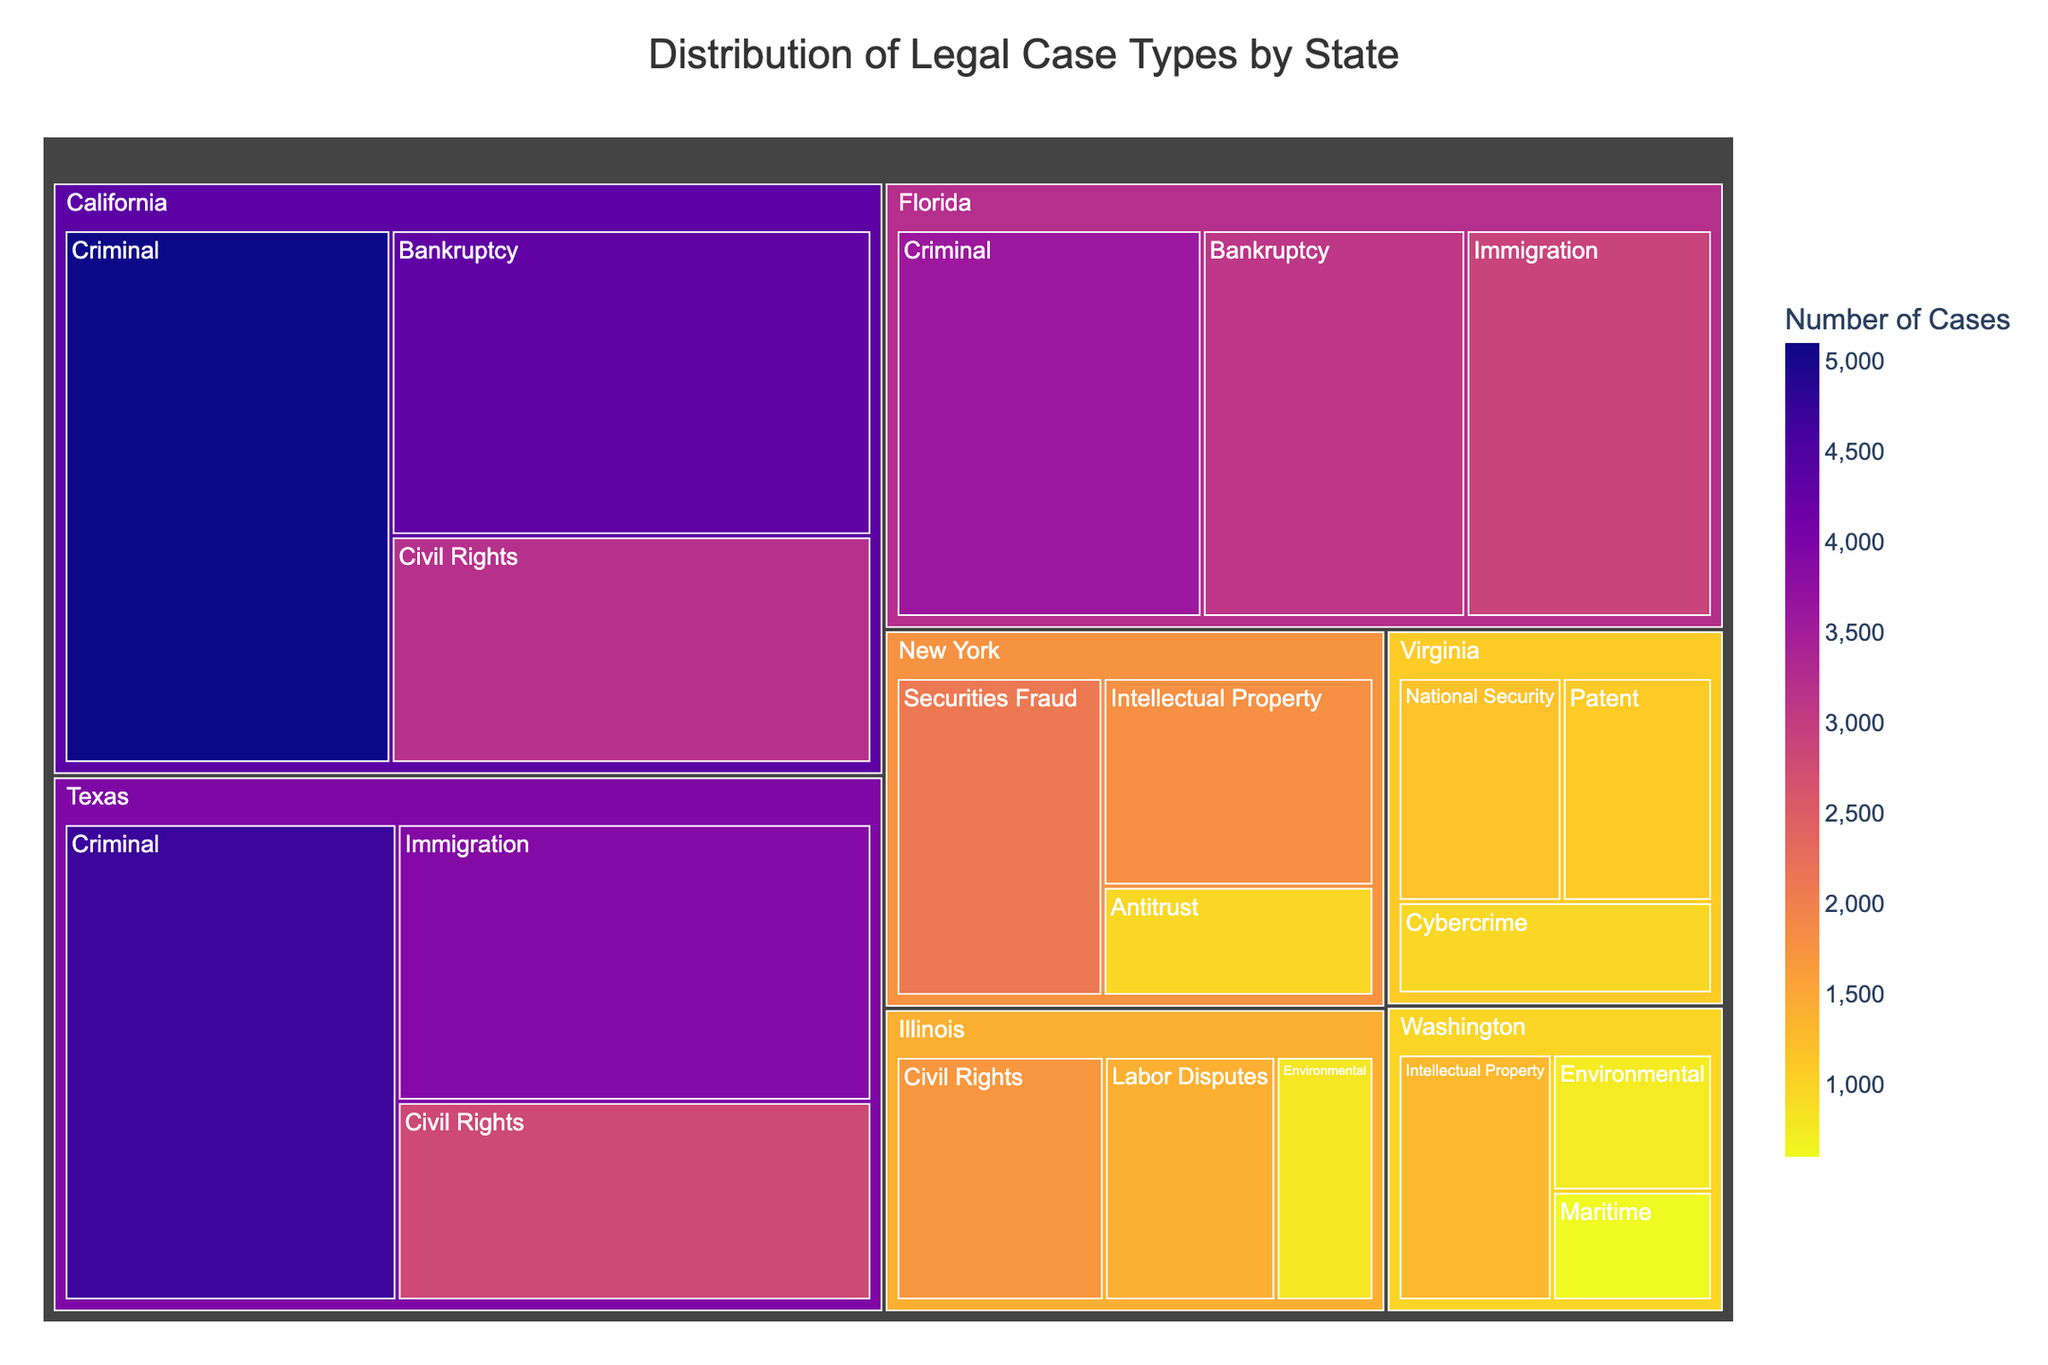What is the title of the treemap? The title is displayed at the top-center of the treemap, indicating the overall theme or topic of the visualization.
Answer: Distribution of Legal Case Types by State Which state has the highest number of total legal cases? By observing the relative size of each state's section on the treemap, we can identify the state covering the largest area.
Answer: California How many criminal cases are there in Texas? Locate Texas on the treemap, then find the section for criminal cases within Texas. The number will be labeled directly in that section.
Answer: 4700 Which state handles the most environmental cases? Find the sections labeled "Environmental" across all states and compare their sizes or the numbers provided. The state with the largest or highest number is the answer.
Answer: Illinois What is the total number of bankruptcy cases in the dataset? Sum the number of bankruptcy cases across all states (California: 4300, Florida: 3100) to get the total.
Answer: 7400 Which case type in New York has the fewest cases? In the section for New York, compare the numbers for each case type and identify the one with the smallest number.
Answer: Antitrust Are there more immigration cases in Texas or Florida? Compare the sizes or numbers of the immigration case sections in Texas and Florida.
Answer: Texas Which state has the maximum variety (different types) of legal cases? Compare the number of different case types within each state's section. The state with the highest count of different cases is the answer.
Answer: California What is the combined number of civil rights cases in California and Illinois? Add the number of civil rights cases in California (3200) and Illinois (1700) to get the total.
Answer: 4900 Does Washington handle more intellectual property cases than New York? Compare the numbers of intellectual property cases for Washington and New York. Washington has 1300, and New York has 1800.
Answer: No 